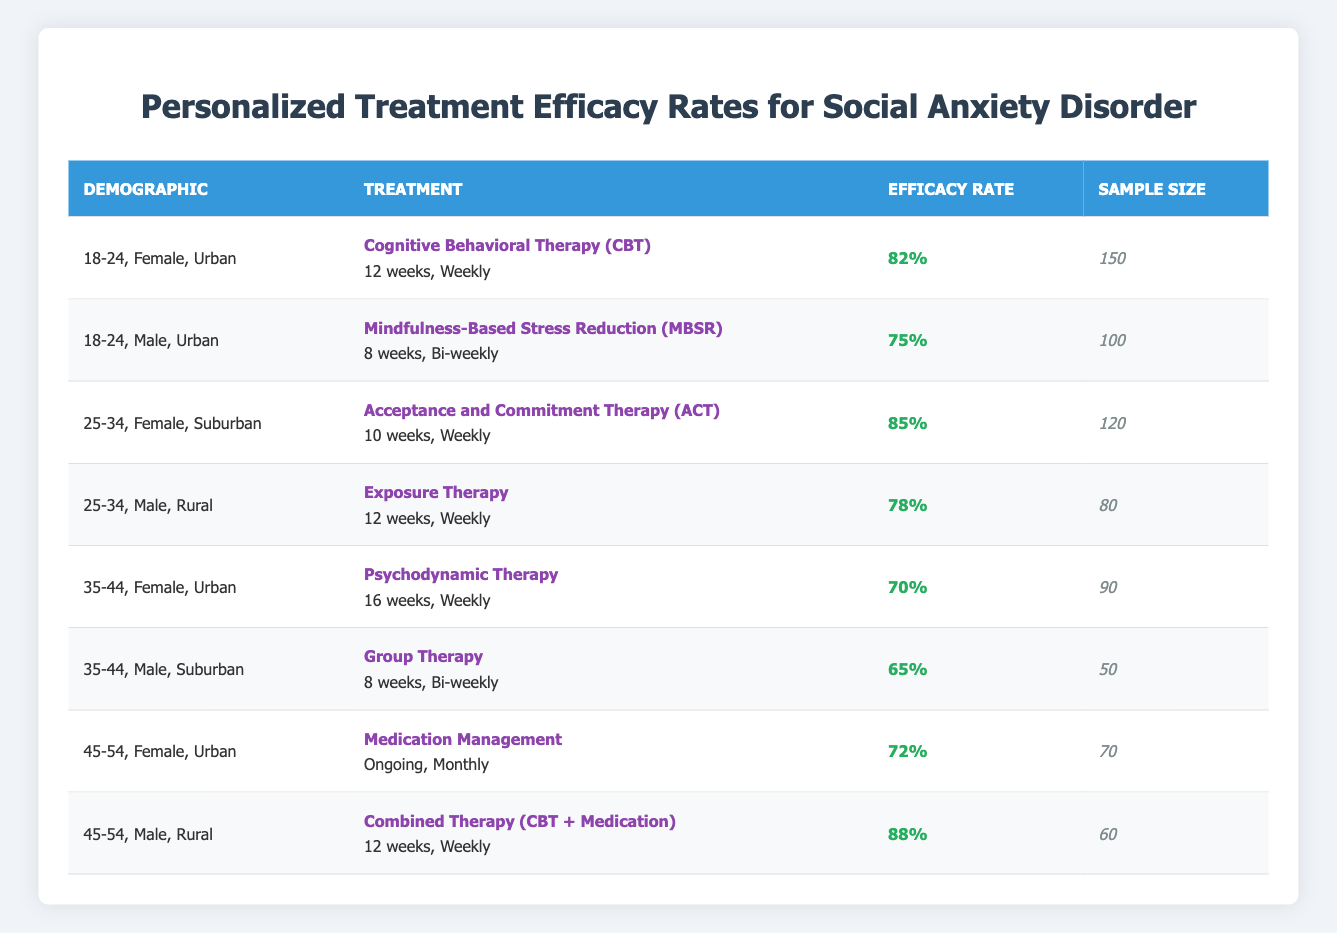What is the efficacy rate of CBT for 18-24-year-old females in urban areas? The table shows that for the demographic of 18-24-year-old females in urban areas, the treatment method is CBT with an efficacy rate of 82%.
Answer: 82% What treatment method has the highest efficacy rate? By checking the efficacy rates for all the treatments, the highest rate is 88% for the Combined Therapy (CBT + Medication) for 45-54-year-old males in rural areas.
Answer: 88% How many participants were involved in the study for 35-44-year-old males in suburban areas? The table indicates that the sample size for 35-44-year-old males receiving Group Therapy is 50.
Answer: 50 What is the average efficacy rate for all treatments listed in the table? To find the average, we sum up all the efficacy rates (82 + 75 + 85 + 78 + 70 + 65 + 72 + 88 = 715) and divide by the number of treatments (8). The average efficacy rate is 715/8 = 89.375%.
Answer: 89.375% Is the efficacy rate for Exposure Therapy higher or lower than 80%? The efficacy rate for Exposure Therapy is 78%, which is lower than 80%.
Answer: Lower What demographic has the highest sample size, and what is that size? The highest sample size in the table is 150, which corresponds to the demographic of 18-24-year-old females in urban areas receiving CBT.
Answer: 150 Is the efficacy rate for females in urban areas who received Psychodynamic Therapy higher than that of males in suburban areas who received Group Therapy? The efficacy rate for females in urban areas receiving Psychodynamic Therapy is 70%, while the efficacy rate for males in suburban areas receiving Group Therapy is 65%. Since 70% > 65%, the answer is yes.
Answer: Yes If we compare the efficacy rates of treatments for those aged 45-54, which treatment shows better efficacy? For the 45-54 age group, the efficacy rate for Medication Management is 72%, while the rate for Combined Therapy is 88%. Since 88% is greater than 72%, Combined Therapy shows better efficacy.
Answer: Combined Therapy What is the difference in efficacy rates between the best and worst treatments listed? The best treatment has an efficacy rate of 88% (Combined Therapy), and the worst has 65% (Group Therapy). The difference is 88% - 65% = 23%.
Answer: 23% 